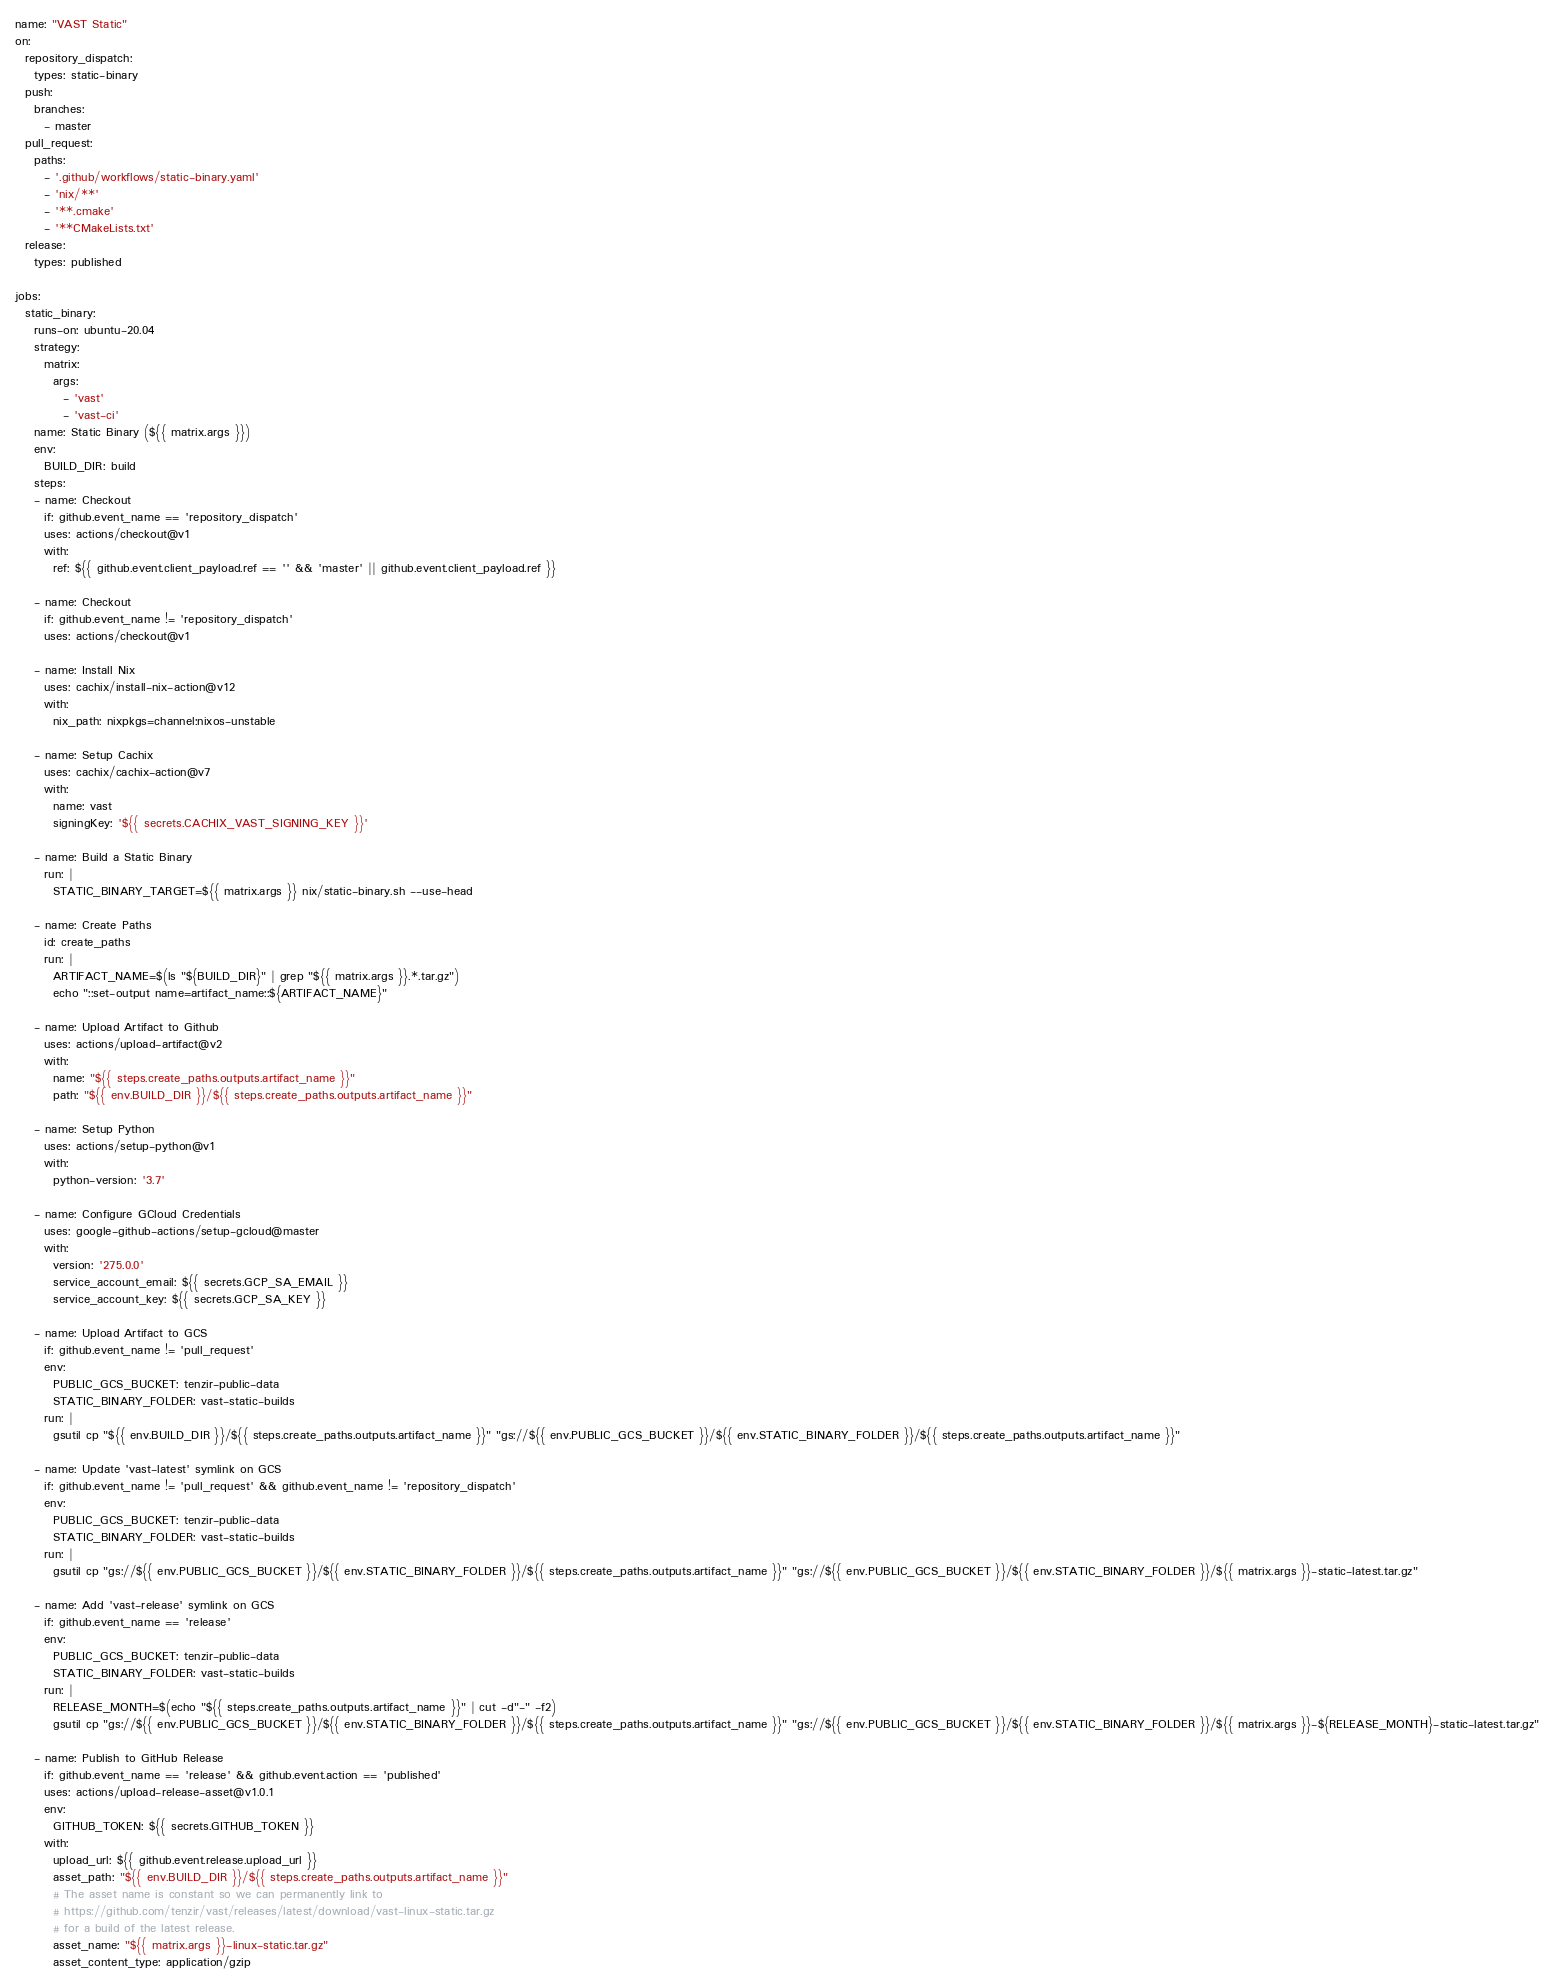Convert code to text. <code><loc_0><loc_0><loc_500><loc_500><_YAML_>name: "VAST Static"
on:
  repository_dispatch:
    types: static-binary
  push:
    branches:
      - master
  pull_request:
    paths:
      - '.github/workflows/static-binary.yaml'
      - 'nix/**'
      - '**.cmake'
      - '**CMakeLists.txt'
  release:
    types: published

jobs:
  static_binary:
    runs-on: ubuntu-20.04
    strategy:
      matrix:
        args:
          - 'vast'
          - 'vast-ci'
    name: Static Binary (${{ matrix.args }})
    env:
      BUILD_DIR: build
    steps:
    - name: Checkout
      if: github.event_name == 'repository_dispatch'
      uses: actions/checkout@v1
      with:
        ref: ${{ github.event.client_payload.ref == '' && 'master' || github.event.client_payload.ref }}

    - name: Checkout
      if: github.event_name != 'repository_dispatch'
      uses: actions/checkout@v1

    - name: Install Nix
      uses: cachix/install-nix-action@v12
      with:
        nix_path: nixpkgs=channel:nixos-unstable

    - name: Setup Cachix
      uses: cachix/cachix-action@v7
      with:
        name: vast
        signingKey: '${{ secrets.CACHIX_VAST_SIGNING_KEY }}'

    - name: Build a Static Binary
      run: |
        STATIC_BINARY_TARGET=${{ matrix.args }} nix/static-binary.sh --use-head

    - name: Create Paths
      id: create_paths
      run: |
        ARTIFACT_NAME=$(ls "${BUILD_DIR}" | grep "${{ matrix.args }}.*.tar.gz")
        echo "::set-output name=artifact_name::${ARTIFACT_NAME}"

    - name: Upload Artifact to Github
      uses: actions/upload-artifact@v2
      with:
        name: "${{ steps.create_paths.outputs.artifact_name }}"
        path: "${{ env.BUILD_DIR }}/${{ steps.create_paths.outputs.artifact_name }}"

    - name: Setup Python
      uses: actions/setup-python@v1
      with:
        python-version: '3.7'

    - name: Configure GCloud Credentials
      uses: google-github-actions/setup-gcloud@master
      with:
        version: '275.0.0'
        service_account_email: ${{ secrets.GCP_SA_EMAIL }}
        service_account_key: ${{ secrets.GCP_SA_KEY }}

    - name: Upload Artifact to GCS
      if: github.event_name != 'pull_request'
      env:
        PUBLIC_GCS_BUCKET: tenzir-public-data
        STATIC_BINARY_FOLDER: vast-static-builds
      run: |
        gsutil cp "${{ env.BUILD_DIR }}/${{ steps.create_paths.outputs.artifact_name }}" "gs://${{ env.PUBLIC_GCS_BUCKET }}/${{ env.STATIC_BINARY_FOLDER }}/${{ steps.create_paths.outputs.artifact_name }}"

    - name: Update 'vast-latest' symlink on GCS
      if: github.event_name != 'pull_request' && github.event_name != 'repository_dispatch'
      env:
        PUBLIC_GCS_BUCKET: tenzir-public-data
        STATIC_BINARY_FOLDER: vast-static-builds
      run: |
        gsutil cp "gs://${{ env.PUBLIC_GCS_BUCKET }}/${{ env.STATIC_BINARY_FOLDER }}/${{ steps.create_paths.outputs.artifact_name }}" "gs://${{ env.PUBLIC_GCS_BUCKET }}/${{ env.STATIC_BINARY_FOLDER }}/${{ matrix.args }}-static-latest.tar.gz"

    - name: Add 'vast-release' symlink on GCS
      if: github.event_name == 'release'
      env:
        PUBLIC_GCS_BUCKET: tenzir-public-data
        STATIC_BINARY_FOLDER: vast-static-builds
      run: |
        RELEASE_MONTH=$(echo "${{ steps.create_paths.outputs.artifact_name }}" | cut -d"-" -f2)
        gsutil cp "gs://${{ env.PUBLIC_GCS_BUCKET }}/${{ env.STATIC_BINARY_FOLDER }}/${{ steps.create_paths.outputs.artifact_name }}" "gs://${{ env.PUBLIC_GCS_BUCKET }}/${{ env.STATIC_BINARY_FOLDER }}/${{ matrix.args }}-${RELEASE_MONTH}-static-latest.tar.gz"

    - name: Publish to GitHub Release
      if: github.event_name == 'release' && github.event.action == 'published'
      uses: actions/upload-release-asset@v1.0.1
      env:
        GITHUB_TOKEN: ${{ secrets.GITHUB_TOKEN }}
      with:
        upload_url: ${{ github.event.release.upload_url }}
        asset_path: "${{ env.BUILD_DIR }}/${{ steps.create_paths.outputs.artifact_name }}"
        # The asset name is constant so we can permanently link to
        # https://github.com/tenzir/vast/releases/latest/download/vast-linux-static.tar.gz
        # for a build of the latest release.
        asset_name: "${{ matrix.args }}-linux-static.tar.gz"
        asset_content_type: application/gzip
</code> 